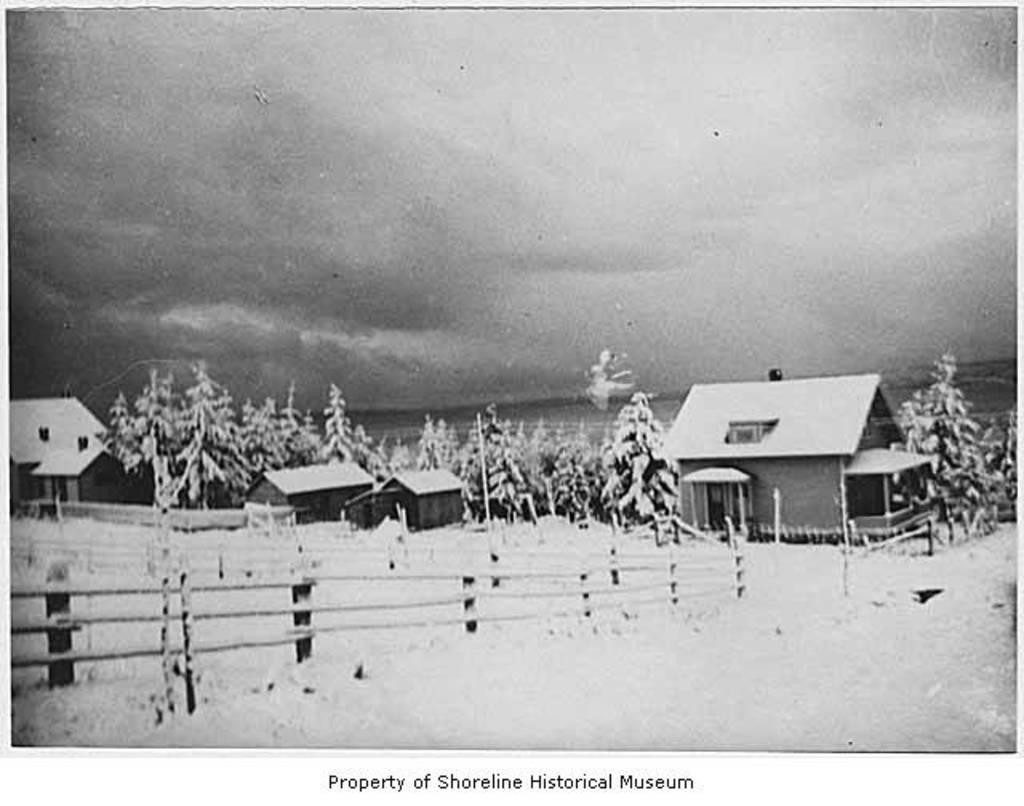What is the color scheme of the image? The image is black and white. What type of structures can be seen in the image? There are houses in the image. What type of barrier is present in the image? There is a fence in the image. What type of vegetation is present in the image? There are trees in the image. What can be seen at the bottom of the image? There is a watermark at the bottom of the image. What type of muscle is visible in the image? There is no muscle visible in the image; it is a black and white image featuring houses, a fence, trees, and a watermark. Can you tell me how many chickens are present in the image? There are no chickens present in the image. 